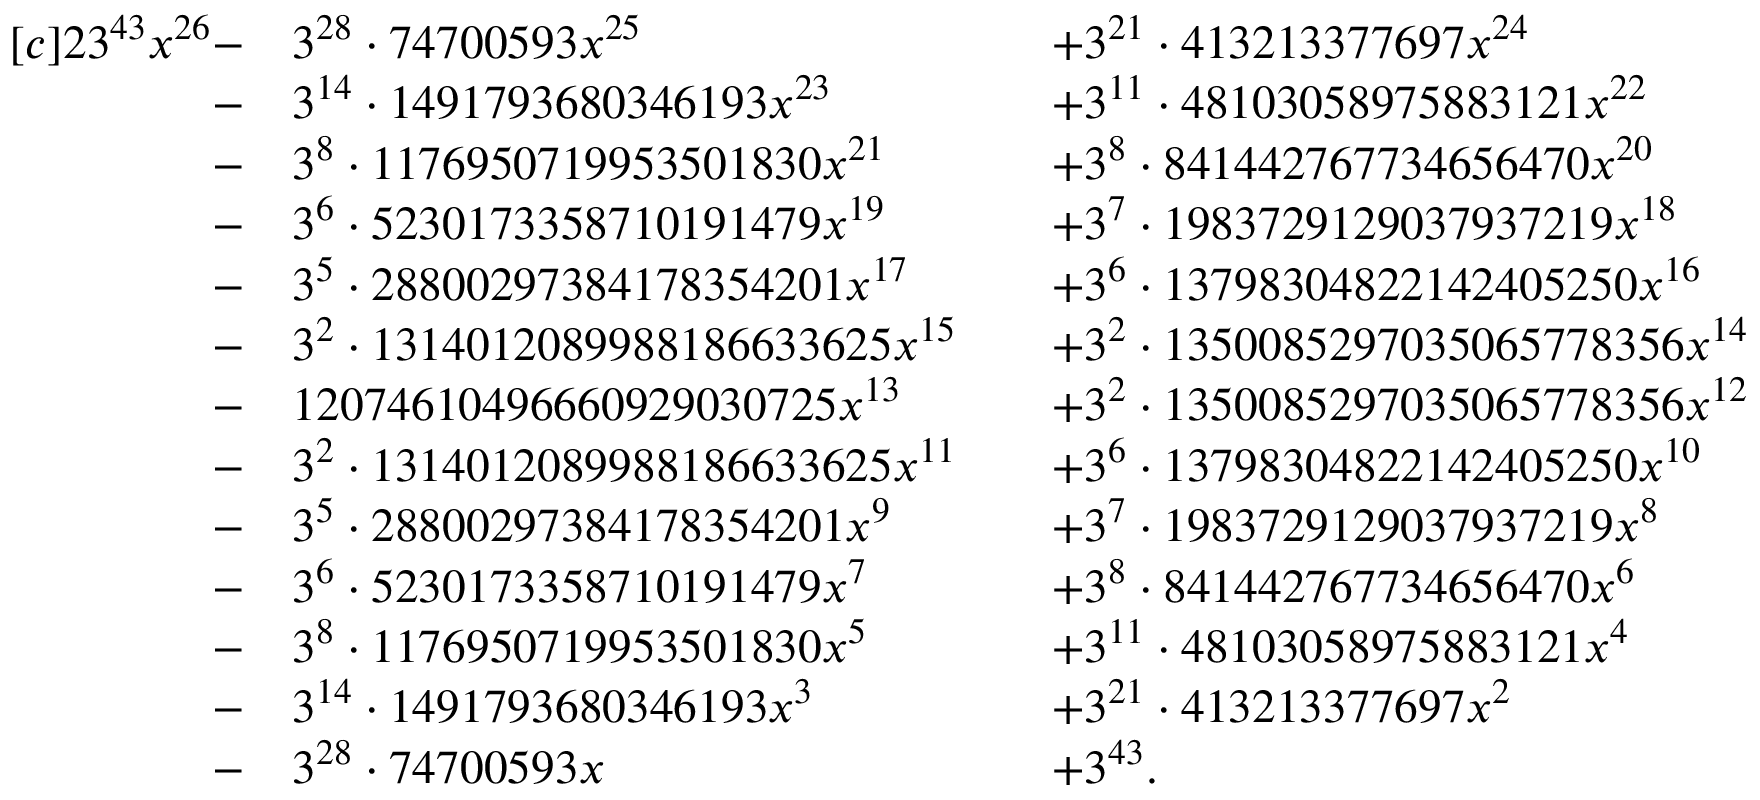Convert formula to latex. <formula><loc_0><loc_0><loc_500><loc_500>\begin{array} { r l r l r l r } { [ c ] { 2 } 3 ^ { 4 3 } x ^ { 2 6 } - } & { 3 ^ { 2 8 } \cdot 7 4 7 0 0 5 9 3 x ^ { 2 5 } } & & { + 3 ^ { 2 1 } \cdot 4 1 3 2 1 3 3 7 7 6 9 7 x ^ { 2 4 } } \\ { - } & { 3 ^ { 1 4 } \cdot 1 4 9 1 7 9 3 6 8 0 3 4 6 1 9 3 x ^ { 2 3 } } & & { + 3 ^ { 1 1 } \cdot 4 8 1 0 3 0 5 8 9 7 5 8 8 3 1 2 1 x ^ { 2 2 } } \\ { - } & { 3 ^ { 8 } \cdot 1 1 7 6 9 5 0 7 1 9 9 5 3 5 0 1 8 3 0 x ^ { 2 1 } } & & { + 3 ^ { 8 } \cdot 8 4 1 4 4 2 7 6 7 7 3 4 6 5 6 4 7 0 x ^ { 2 0 } } \\ { - } & { 3 ^ { 6 } \cdot 5 2 3 0 1 7 3 3 5 8 7 1 0 1 9 1 4 7 9 x ^ { 1 9 } } & & { + 3 ^ { 7 } \cdot 1 9 8 3 7 2 9 1 2 9 0 3 7 9 3 7 2 1 9 x ^ { 1 8 } } \\ { - } & { 3 ^ { 5 } \cdot 2 8 8 0 0 2 9 7 3 8 4 1 7 8 3 5 4 2 0 1 x ^ { 1 7 } } & & { + 3 ^ { 6 } \cdot 1 3 7 9 8 3 0 4 8 2 2 1 4 2 4 0 5 2 5 0 x ^ { 1 6 } } \\ { - } & { 3 ^ { 2 } \cdot 1 3 1 4 0 1 2 0 8 9 9 8 8 1 8 6 6 3 3 6 2 5 x ^ { 1 5 } } & & { + 3 ^ { 2 } \cdot 1 3 5 0 0 8 5 2 9 7 0 3 5 0 6 5 7 7 8 3 5 6 x ^ { 1 4 } } \\ { - } & { 1 2 0 7 4 6 1 0 4 9 6 6 6 0 9 2 9 0 3 0 7 2 5 x ^ { 1 3 } } & & { + 3 ^ { 2 } \cdot 1 3 5 0 0 8 5 2 9 7 0 3 5 0 6 5 7 7 8 3 5 6 x ^ { 1 2 } } \\ { - } & { 3 ^ { 2 } \cdot 1 3 1 4 0 1 2 0 8 9 9 8 8 1 8 6 6 3 3 6 2 5 x ^ { 1 1 } } & & { + 3 ^ { 6 } \cdot 1 3 7 9 8 3 0 4 8 2 2 1 4 2 4 0 5 2 5 0 x ^ { 1 0 } } \\ { - } & { 3 ^ { 5 } \cdot 2 8 8 0 0 2 9 7 3 8 4 1 7 8 3 5 4 2 0 1 x ^ { 9 } } & & { + 3 ^ { 7 } \cdot 1 9 8 3 7 2 9 1 2 9 0 3 7 9 3 7 2 1 9 x ^ { 8 } } \\ { - } & { 3 ^ { 6 } \cdot 5 2 3 0 1 7 3 3 5 8 7 1 0 1 9 1 4 7 9 x ^ { 7 } } & & { + 3 ^ { 8 } \cdot 8 4 1 4 4 2 7 6 7 7 3 4 6 5 6 4 7 0 x ^ { 6 } } \\ { - } & { 3 ^ { 8 } \cdot 1 1 7 6 9 5 0 7 1 9 9 5 3 5 0 1 8 3 0 x ^ { 5 } } & & { + 3 ^ { 1 1 } \cdot 4 8 1 0 3 0 5 8 9 7 5 8 8 3 1 2 1 x ^ { 4 } } \\ { - } & { 3 ^ { 1 4 } \cdot 1 4 9 1 7 9 3 6 8 0 3 4 6 1 9 3 x ^ { 3 } } & & { + 3 ^ { 2 1 } \cdot 4 1 3 2 1 3 3 7 7 6 9 7 x ^ { 2 } } \\ { - } & { 3 ^ { 2 8 } \cdot 7 4 7 0 0 5 9 3 x } & & { + 3 ^ { 4 3 } . } & & \end{array}</formula> 